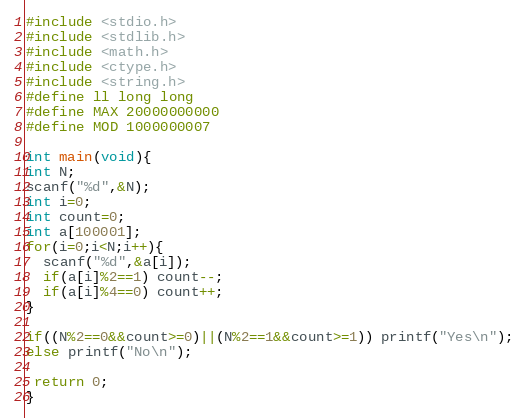Convert code to text. <code><loc_0><loc_0><loc_500><loc_500><_C_>#include <stdio.h>
#include <stdlib.h>
#include <math.h>
#include <ctype.h>
#include <string.h>
#define ll long long
#define MAX 20000000000
#define MOD 1000000007

int main(void){
int N;
scanf("%d",&N);
int i=0;
int count=0;
int a[100001];
for(i=0;i<N;i++){
  scanf("%d",&a[i]);
  if(a[i]%2==1) count--;
  if(a[i]%4==0) count++;
}

if((N%2==0&&count>=0)||(N%2==1&&count>=1)) printf("Yes\n");
else printf("No\n");

 return 0;
}</code> 